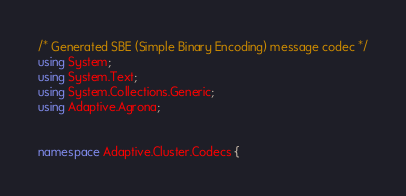<code> <loc_0><loc_0><loc_500><loc_500><_C#_>/* Generated SBE (Simple Binary Encoding) message codec */
using System;
using System.Text;
using System.Collections.Generic;
using Adaptive.Agrona;


namespace Adaptive.Cluster.Codecs {
</code> 